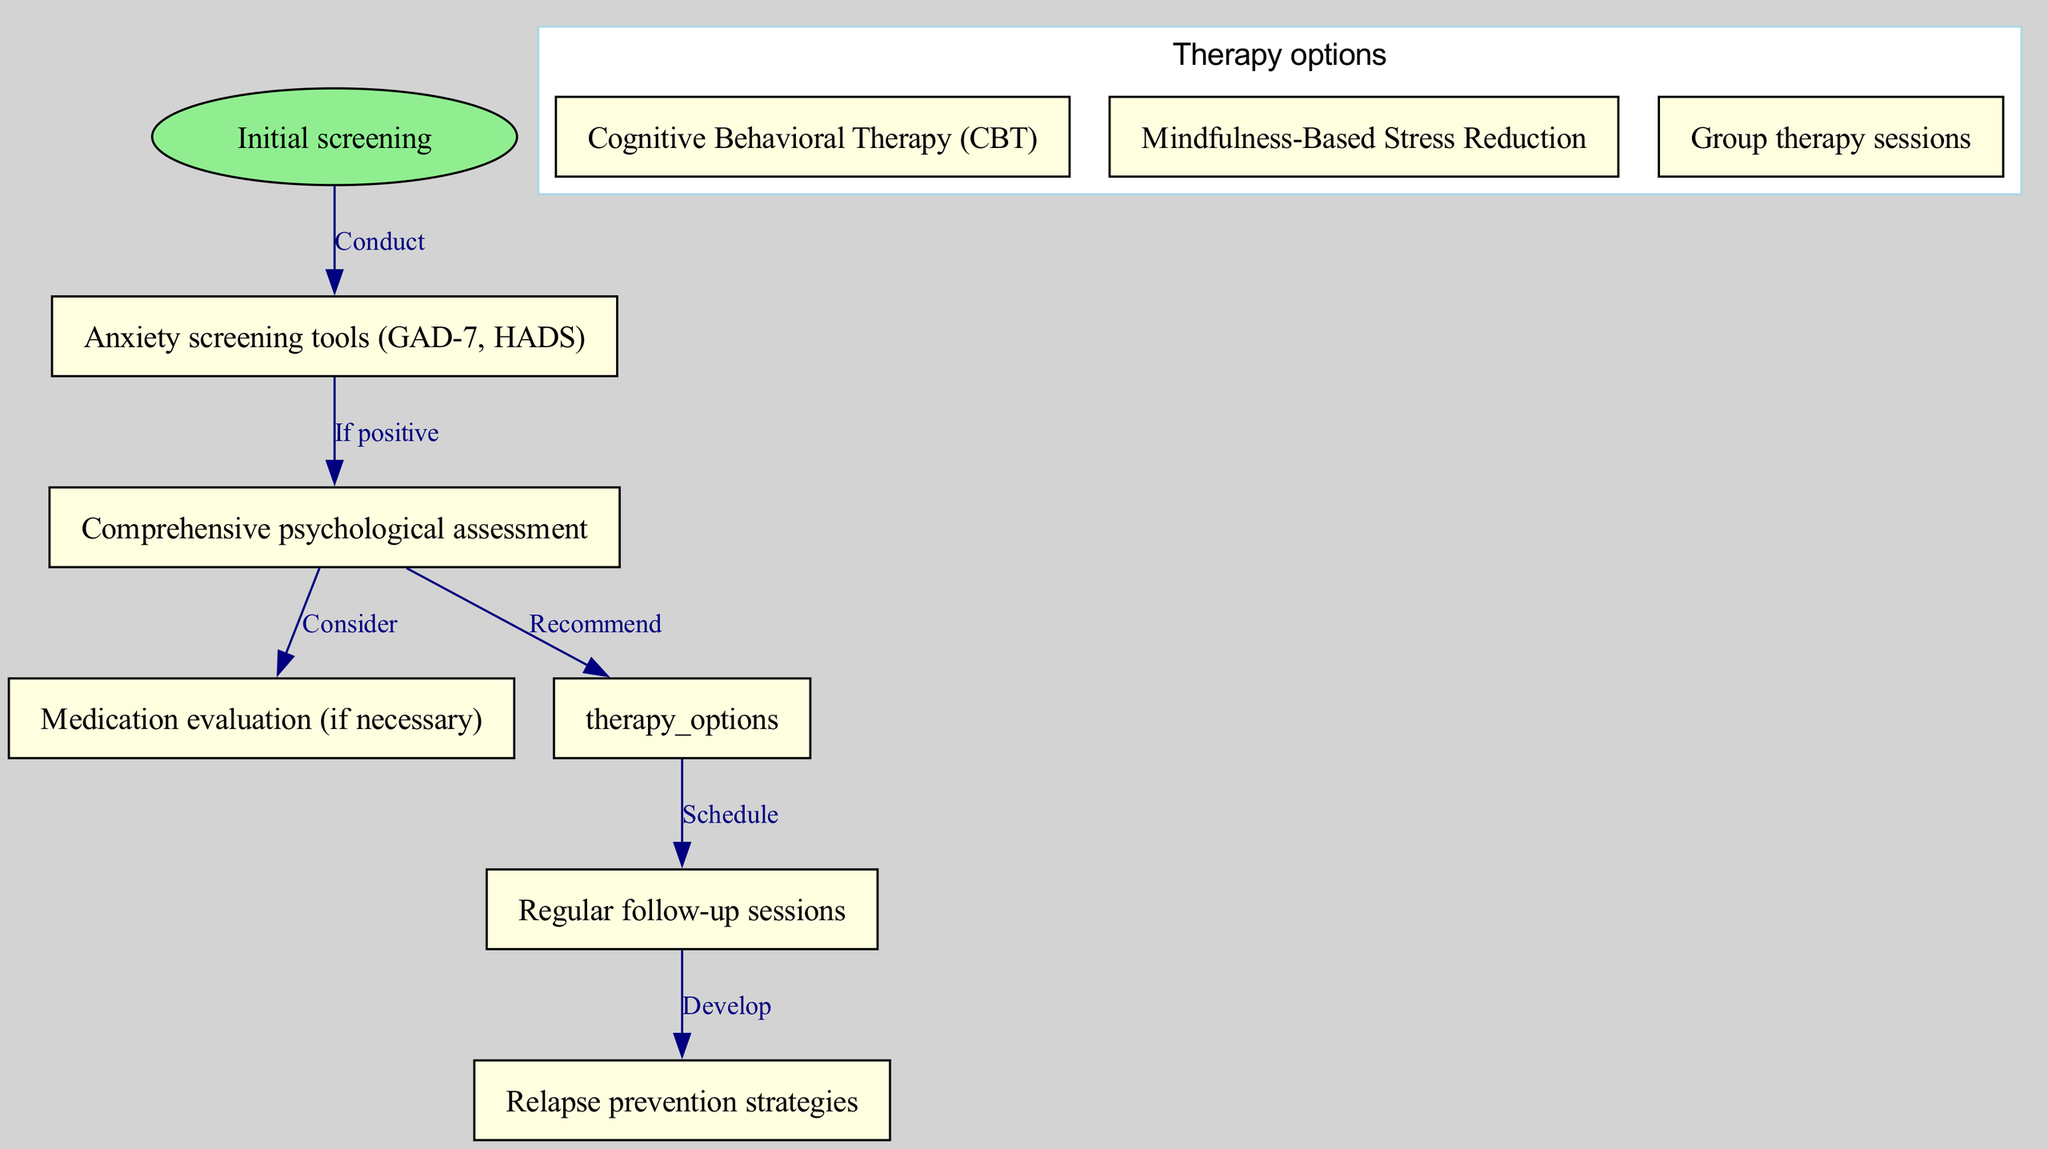What is the initial step in the clinical pathway? The diagram shows that the initial step in the pathway is "Initial screening," which is indicated as the starting point of the flow.
Answer: Initial screening How many therapy options are listed? The diagram includes a node labeled "Therapy options," which contains three children nodes: CBT, Mindfulness-Based Stress Reduction, and Group therapy sessions. Therefore, there are a total of three therapy options.
Answer: 3 What happens after a positive screening? The edge from "screening" to "assessment" indicates that if the screening is positive, the flow proceeds to "Comprehensive psychological assessment."
Answer: Comprehensive psychological assessment Which node is reached after scheduling therapy options? Following the edge from "therapy options," the next node according to the flow is "Regular follow-up sessions."
Answer: Regular follow-up sessions What is developed after regular follow-up sessions? The diagram shows an edge leading from "follow up" to "relapse prevention," indicating that after regular follow-up sessions, the next step is to develop relapse prevention strategies.
Answer: Relapse prevention strategies What type of therapy is listed as the first option? Within the "therapy options" node, the first child node listed is "Cognitive Behavioral Therapy (CBT)," making it the first therapy option available.
Answer: Cognitive Behavioral Therapy (CBT) Does the diagram include medication evaluation in the pathway? Yes, the diagram includes a node for "Medication evaluation (if necessary)," which is a part of the pathway after the assessment stage, indicating its consideration in treatment.
Answer: Yes After a comprehensive psychological assessment, what two paths can be taken? From the "assessment" node, two edges lead outward: one to "Therapy options" indicating a recommendation for therapy, and another to "Medication evaluation" suggesting a consideration for medication.
Answer: Therapy options and Medication evaluation 